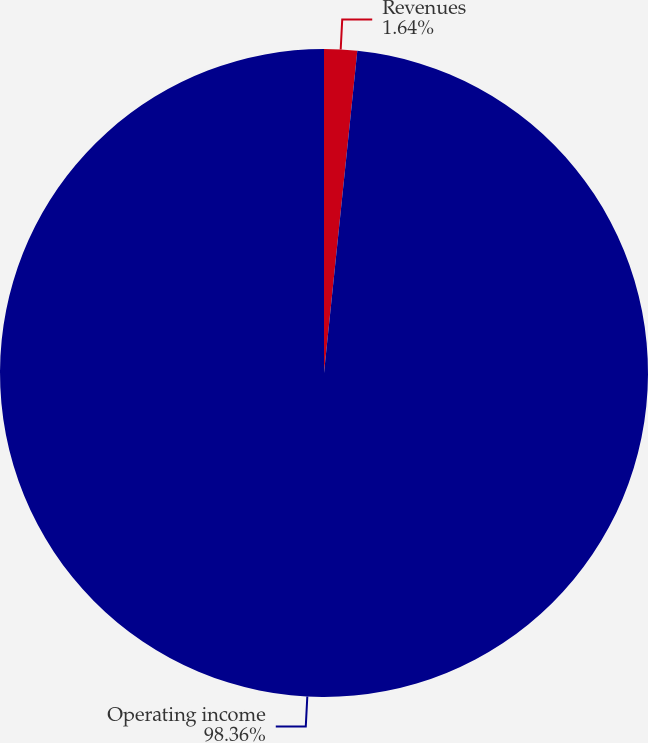Convert chart to OTSL. <chart><loc_0><loc_0><loc_500><loc_500><pie_chart><fcel>Revenues<fcel>Operating income<nl><fcel>1.64%<fcel>98.36%<nl></chart> 